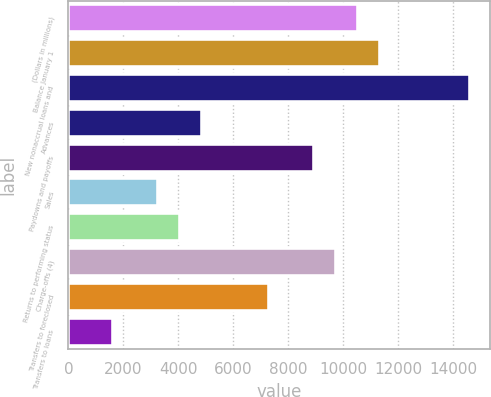Convert chart. <chart><loc_0><loc_0><loc_500><loc_500><bar_chart><fcel>(Dollars in millions)<fcel>Balance January 1<fcel>New nonaccrual loans and<fcel>Advances<fcel>Paydowns and payoffs<fcel>Sales<fcel>Returns to performing status<fcel>Charge-offs (4)<fcel>Transfers to foreclosed<fcel>Transfers to loans<nl><fcel>10542.5<fcel>11353.3<fcel>14596.5<fcel>4866.79<fcel>8920.84<fcel>3245.17<fcel>4055.98<fcel>9731.65<fcel>7299.22<fcel>1623.55<nl></chart> 